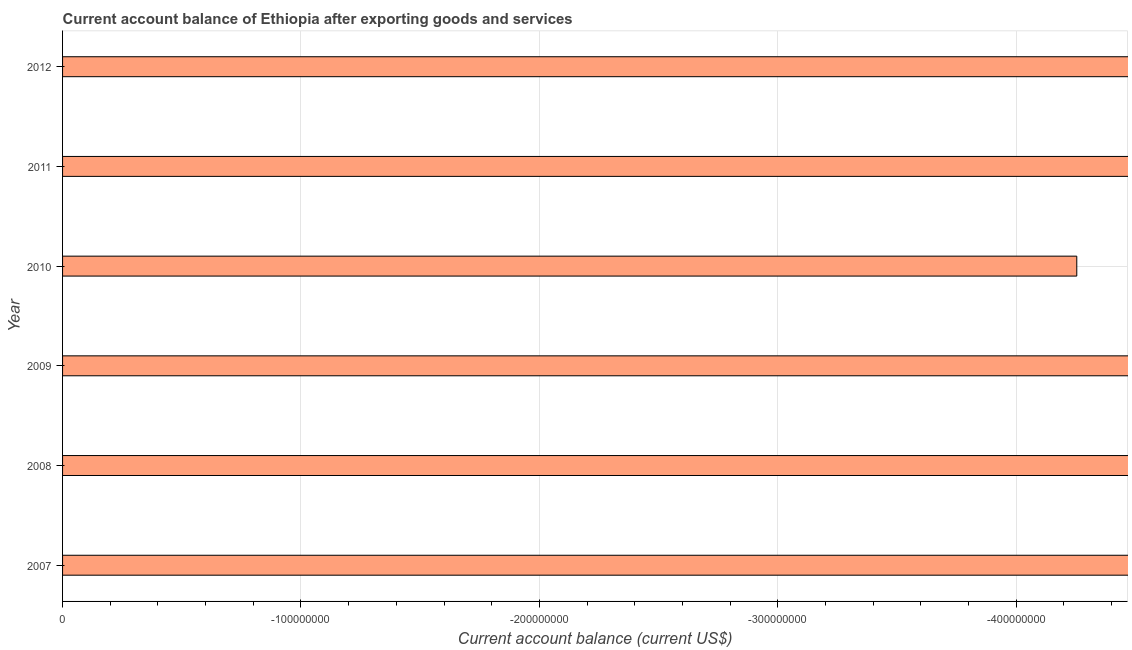Does the graph contain any zero values?
Your answer should be very brief. Yes. Does the graph contain grids?
Give a very brief answer. Yes. What is the title of the graph?
Give a very brief answer. Current account balance of Ethiopia after exporting goods and services. What is the label or title of the X-axis?
Provide a short and direct response. Current account balance (current US$). What is the label or title of the Y-axis?
Offer a terse response. Year. What is the current account balance in 2009?
Your response must be concise. 0. What is the sum of the current account balance?
Offer a very short reply. 0. What is the average current account balance per year?
Offer a very short reply. 0. In how many years, is the current account balance greater than the average current account balance taken over all years?
Your answer should be compact. 0. Are all the bars in the graph horizontal?
Provide a short and direct response. Yes. What is the Current account balance (current US$) of 2008?
Provide a short and direct response. 0. What is the Current account balance (current US$) of 2012?
Offer a very short reply. 0. 